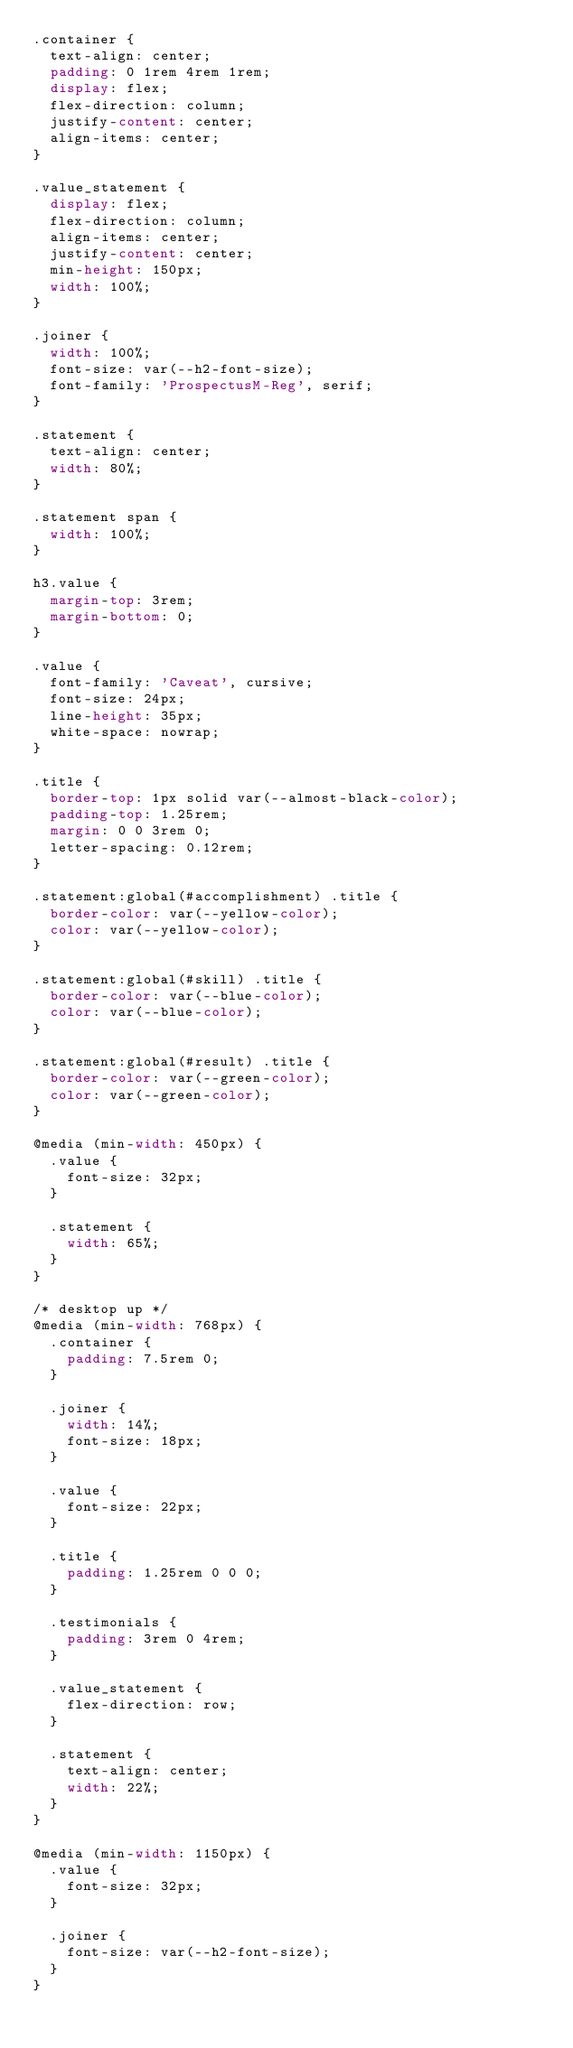Convert code to text. <code><loc_0><loc_0><loc_500><loc_500><_CSS_>.container {
  text-align: center;
  padding: 0 1rem 4rem 1rem;
  display: flex;
  flex-direction: column;
  justify-content: center;
  align-items: center;
}

.value_statement {
  display: flex;
  flex-direction: column;
  align-items: center;
  justify-content: center;
  min-height: 150px;
  width: 100%;
}

.joiner {
  width: 100%;
  font-size: var(--h2-font-size);
  font-family: 'ProspectusM-Reg', serif;
}

.statement {
  text-align: center;
  width: 80%;
}

.statement span {
  width: 100%;
}

h3.value {
  margin-top: 3rem;
  margin-bottom: 0;
}

.value {
  font-family: 'Caveat', cursive;
  font-size: 24px;
  line-height: 35px;
  white-space: nowrap;
}

.title {
  border-top: 1px solid var(--almost-black-color);
  padding-top: 1.25rem;
  margin: 0 0 3rem 0;
  letter-spacing: 0.12rem;
}

.statement:global(#accomplishment) .title {
  border-color: var(--yellow-color);
  color: var(--yellow-color);
}

.statement:global(#skill) .title {
  border-color: var(--blue-color);
  color: var(--blue-color);
}

.statement:global(#result) .title {
  border-color: var(--green-color);
  color: var(--green-color);
}

@media (min-width: 450px) {
  .value {
    font-size: 32px;
  }

  .statement {
    width: 65%;
  }
}

/* desktop up */
@media (min-width: 768px) {
  .container {
    padding: 7.5rem 0;
  }

  .joiner {
    width: 14%;
    font-size: 18px;
  }

  .value {
    font-size: 22px;
  }

  .title {
    padding: 1.25rem 0 0 0;
  }

  .testimonials {
    padding: 3rem 0 4rem;
  }

  .value_statement {
    flex-direction: row;
  }

  .statement {
    text-align: center;
    width: 22%;
  }
}

@media (min-width: 1150px) {
  .value {
    font-size: 32px;
  }

  .joiner {
    font-size: var(--h2-font-size);
  }
}
</code> 